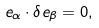Convert formula to latex. <formula><loc_0><loc_0><loc_500><loc_500>e _ { \alpha } \cdot \delta e _ { \beta } = 0 ,</formula> 